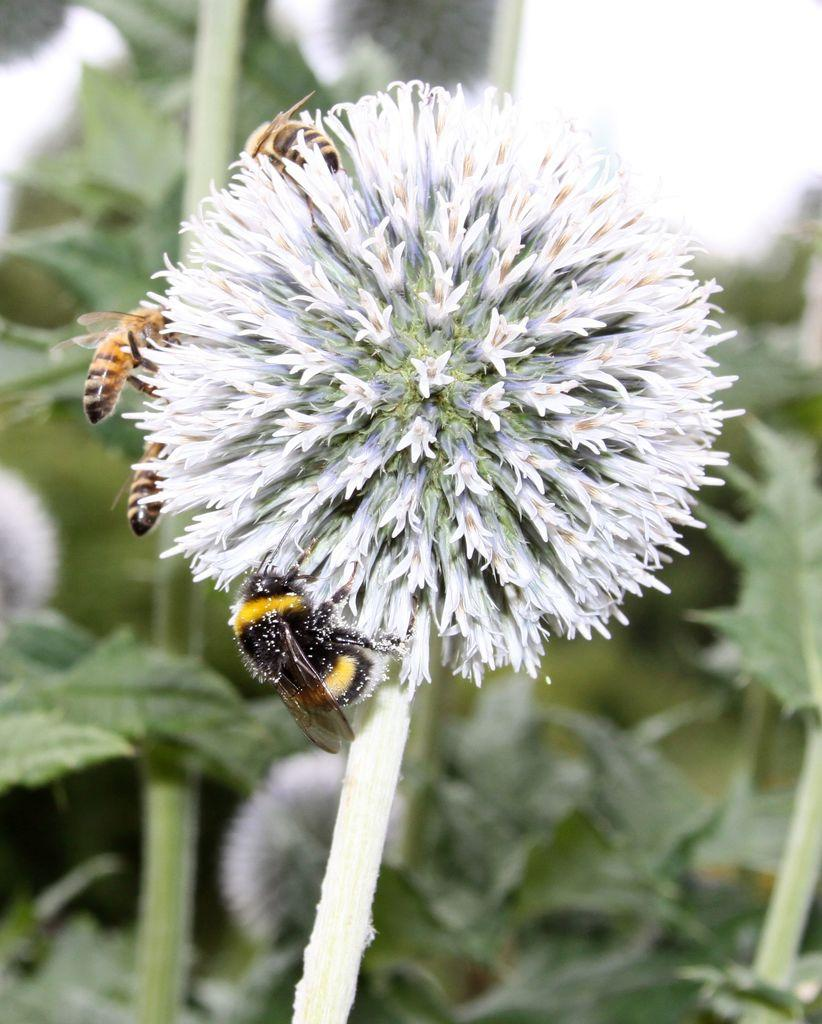What is the main subject of the image? There is a flower in the image. Are there any other living organisms present on the flower? Yes, there are 4 honey bees on the flower. What can be seen in the background of the image? There are leaves visible in the background of the image. How would you describe the background of the image? The background appears blurred. What type of grain is being harvested in the image? There is no grain present in the image; it features a flower with honey bees and a blurred background. 